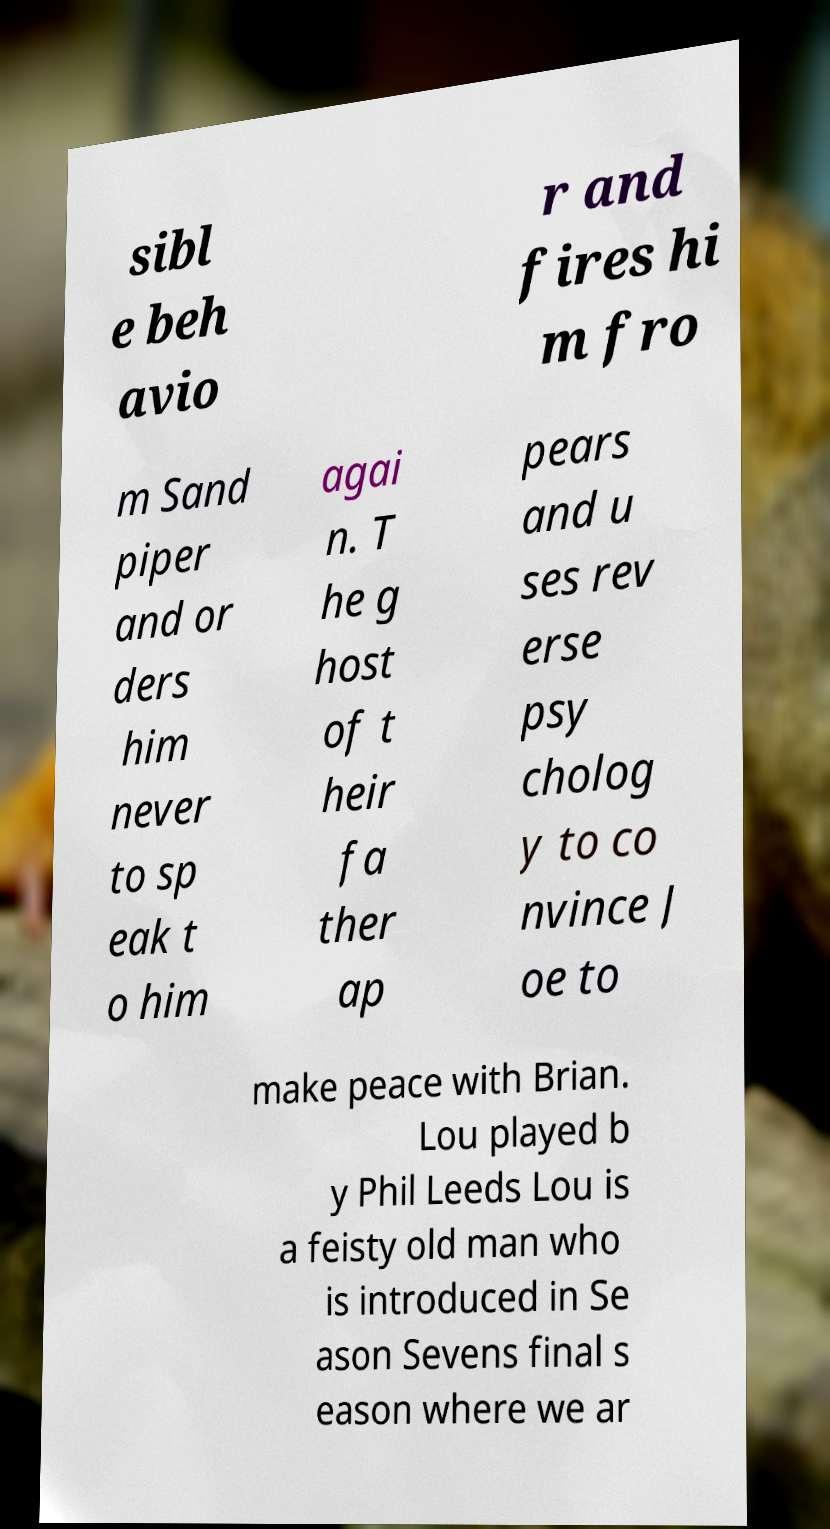For documentation purposes, I need the text within this image transcribed. Could you provide that? sibl e beh avio r and fires hi m fro m Sand piper and or ders him never to sp eak t o him agai n. T he g host of t heir fa ther ap pears and u ses rev erse psy cholog y to co nvince J oe to make peace with Brian. Lou played b y Phil Leeds Lou is a feisty old man who is introduced in Se ason Sevens final s eason where we ar 